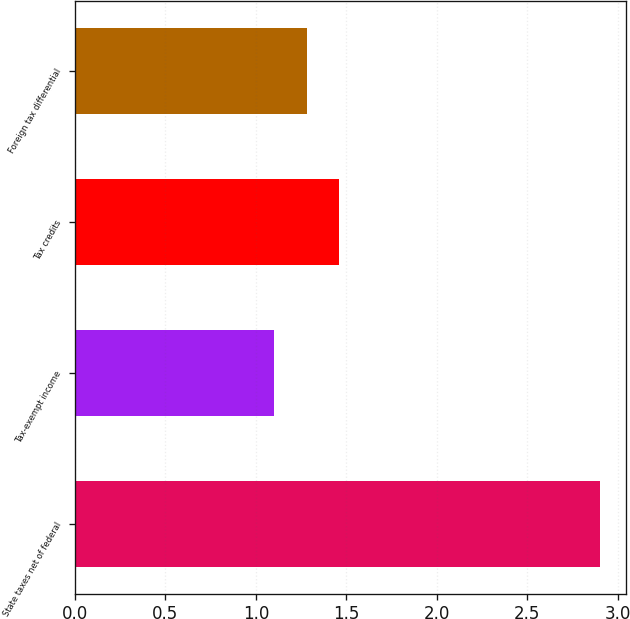Convert chart to OTSL. <chart><loc_0><loc_0><loc_500><loc_500><bar_chart><fcel>State taxes net of federal<fcel>Tax-exempt income<fcel>Tax credits<fcel>Foreign tax differential<nl><fcel>2.9<fcel>1.1<fcel>1.46<fcel>1.28<nl></chart> 